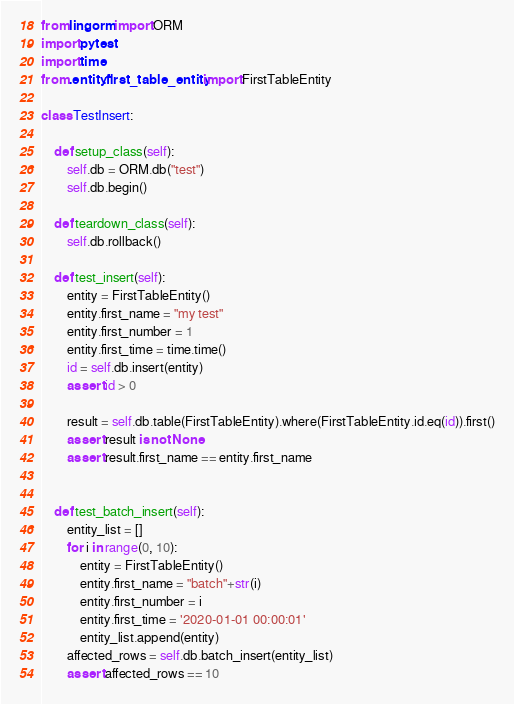Convert code to text. <code><loc_0><loc_0><loc_500><loc_500><_Python_>from lingorm import ORM
import pytest
import time
from .entity.first_table_entity import FirstTableEntity

class TestInsert:

    def setup_class(self):
        self.db = ORM.db("test")
        self.db.begin()

    def teardown_class(self):
        self.db.rollback()

    def test_insert(self):
        entity = FirstTableEntity()
        entity.first_name = "my test"
        entity.first_number = 1
        entity.first_time = time.time()
        id = self.db.insert(entity)
        assert id > 0

        result = self.db.table(FirstTableEntity).where(FirstTableEntity.id.eq(id)).first()
        assert result is not None
        assert result.first_name == entity.first_name


    def test_batch_insert(self):
        entity_list = []
        for i in range(0, 10):
            entity = FirstTableEntity()
            entity.first_name = "batch"+str(i)
            entity.first_number = i
            entity.first_time = '2020-01-01 00:00:01'
            entity_list.append(entity)
        affected_rows = self.db.batch_insert(entity_list)
        assert affected_rows == 10
</code> 